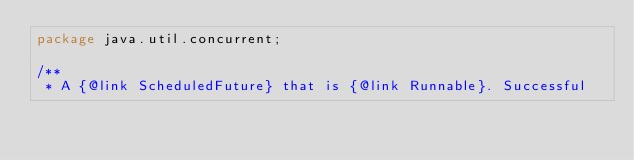Convert code to text. <code><loc_0><loc_0><loc_500><loc_500><_Java_>package java.util.concurrent;

/**
 * A {@link ScheduledFuture} that is {@link Runnable}. Successful</code> 